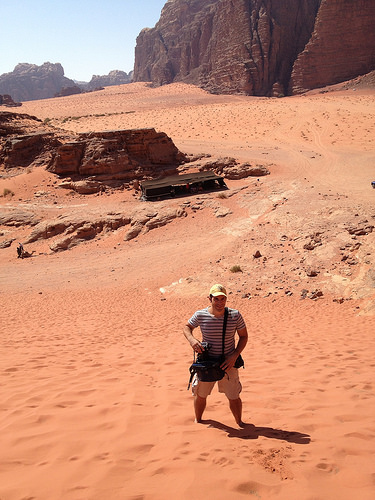<image>
Is the tent to the left of the man? No. The tent is not to the left of the man. From this viewpoint, they have a different horizontal relationship. Where is the man in relation to the desert? Is it behind the desert? No. The man is not behind the desert. From this viewpoint, the man appears to be positioned elsewhere in the scene. Is there a man in the sand? Yes. The man is contained within or inside the sand, showing a containment relationship. 